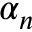<formula> <loc_0><loc_0><loc_500><loc_500>\alpha _ { n }</formula> 